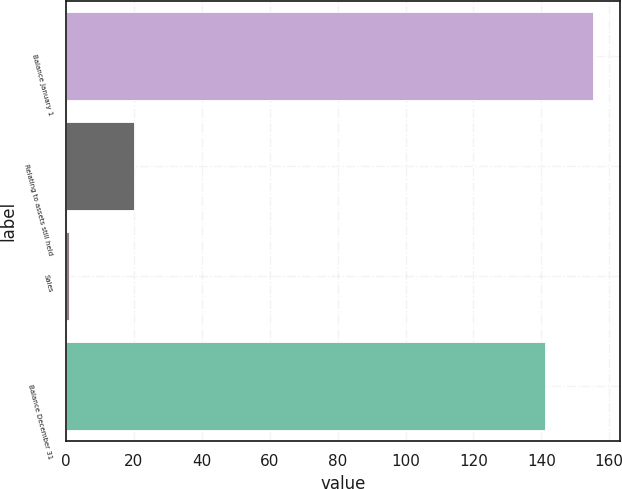Convert chart. <chart><loc_0><loc_0><loc_500><loc_500><bar_chart><fcel>Balance January 1<fcel>Relating to assets still held<fcel>Sales<fcel>Balance December 31<nl><fcel>155.3<fcel>20<fcel>1<fcel>141<nl></chart> 